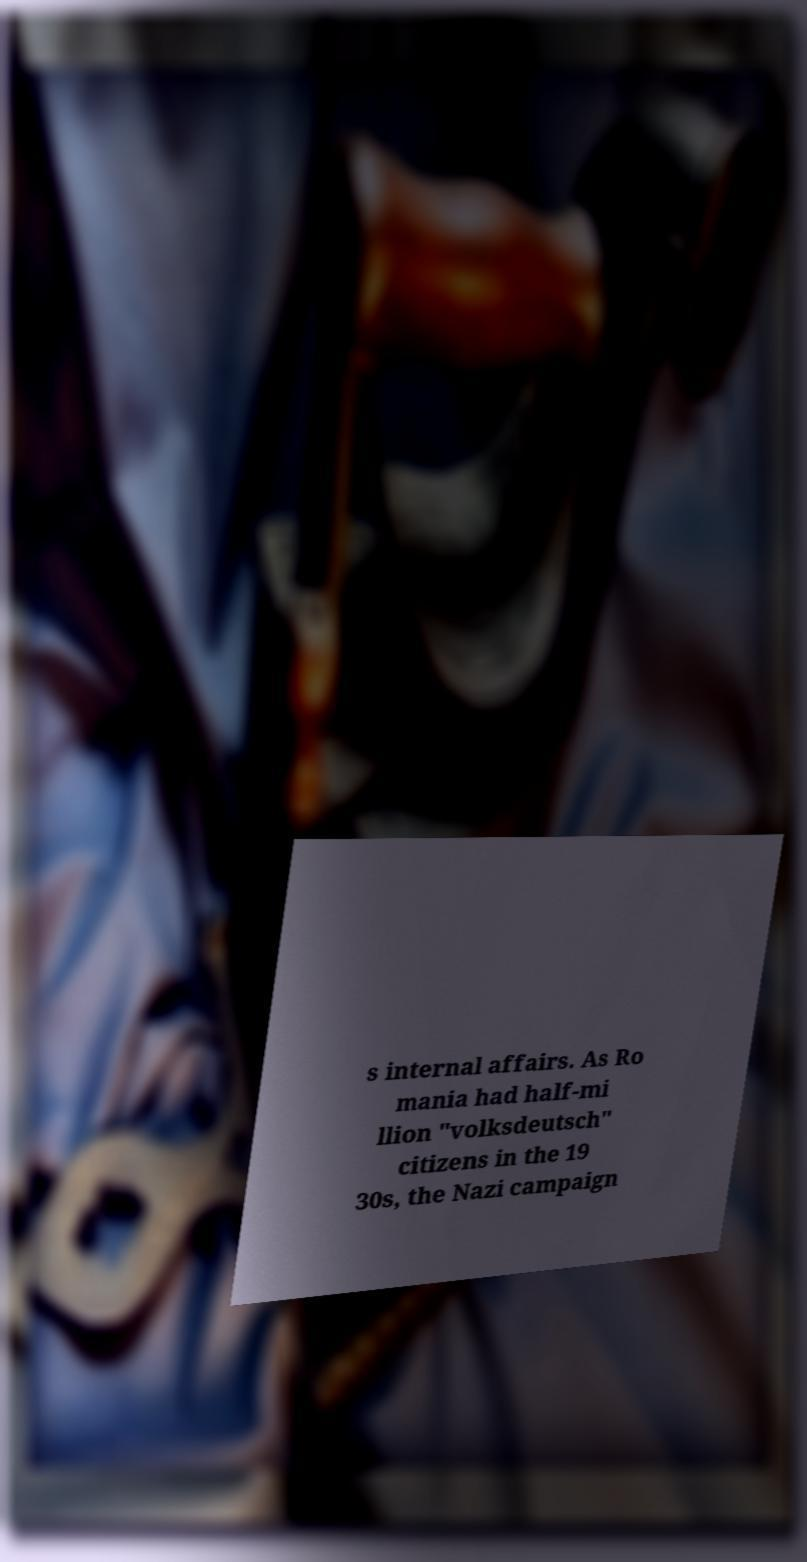I need the written content from this picture converted into text. Can you do that? s internal affairs. As Ro mania had half-mi llion "volksdeutsch" citizens in the 19 30s, the Nazi campaign 